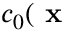<formula> <loc_0><loc_0><loc_500><loc_500>c _ { 0 } ( x</formula> 